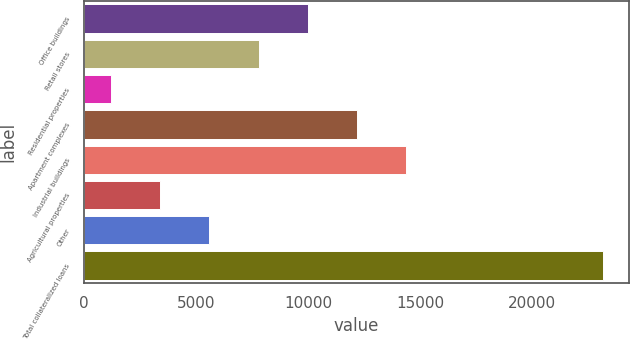Convert chart to OTSL. <chart><loc_0><loc_0><loc_500><loc_500><bar_chart><fcel>Office buildings<fcel>Retail stores<fcel>Residential properties<fcel>Apartment complexes<fcel>Industrial buildings<fcel>Agricultural properties<fcel>Other<fcel>Total collateralized loans<nl><fcel>9984.8<fcel>7788.1<fcel>1198<fcel>12181.5<fcel>14378.2<fcel>3394.7<fcel>5591.4<fcel>23165<nl></chart> 